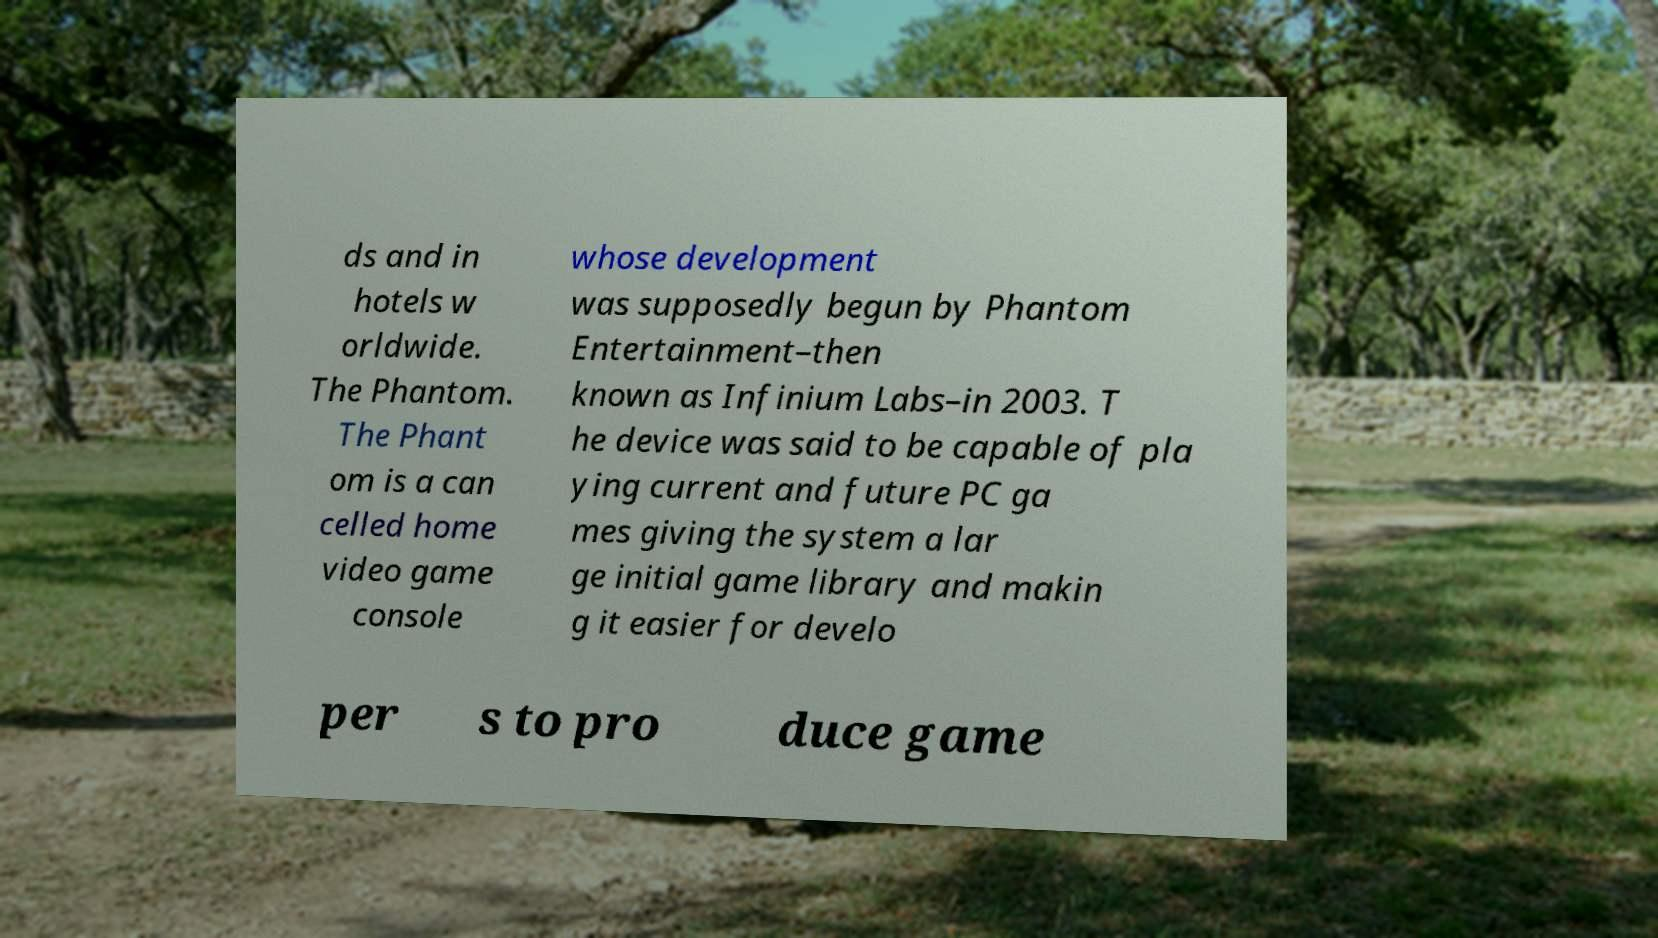Please identify and transcribe the text found in this image. ds and in hotels w orldwide. The Phantom. The Phant om is a can celled home video game console whose development was supposedly begun by Phantom Entertainment–then known as Infinium Labs–in 2003. T he device was said to be capable of pla ying current and future PC ga mes giving the system a lar ge initial game library and makin g it easier for develo per s to pro duce game 